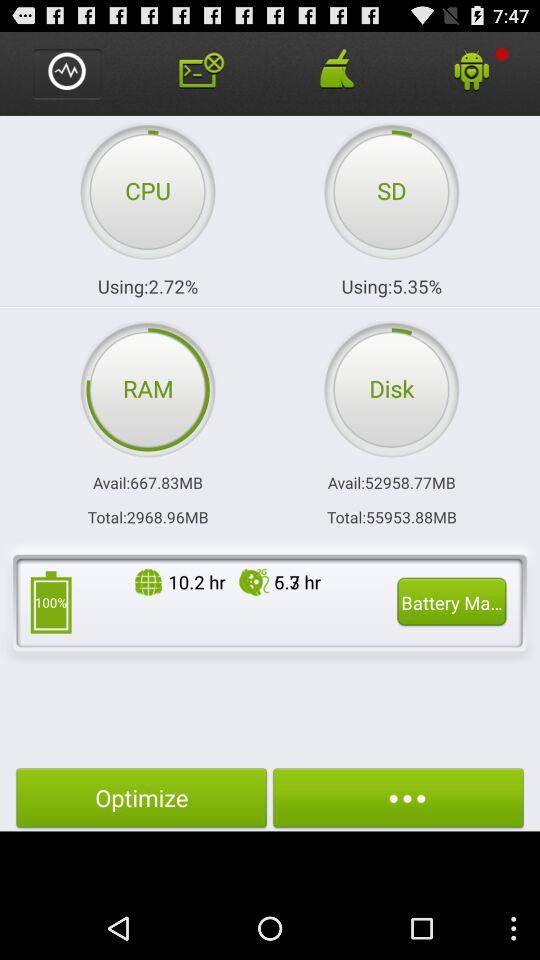What is the total size of the disk in MB? The total size of the disk is 55953.88 MB. 